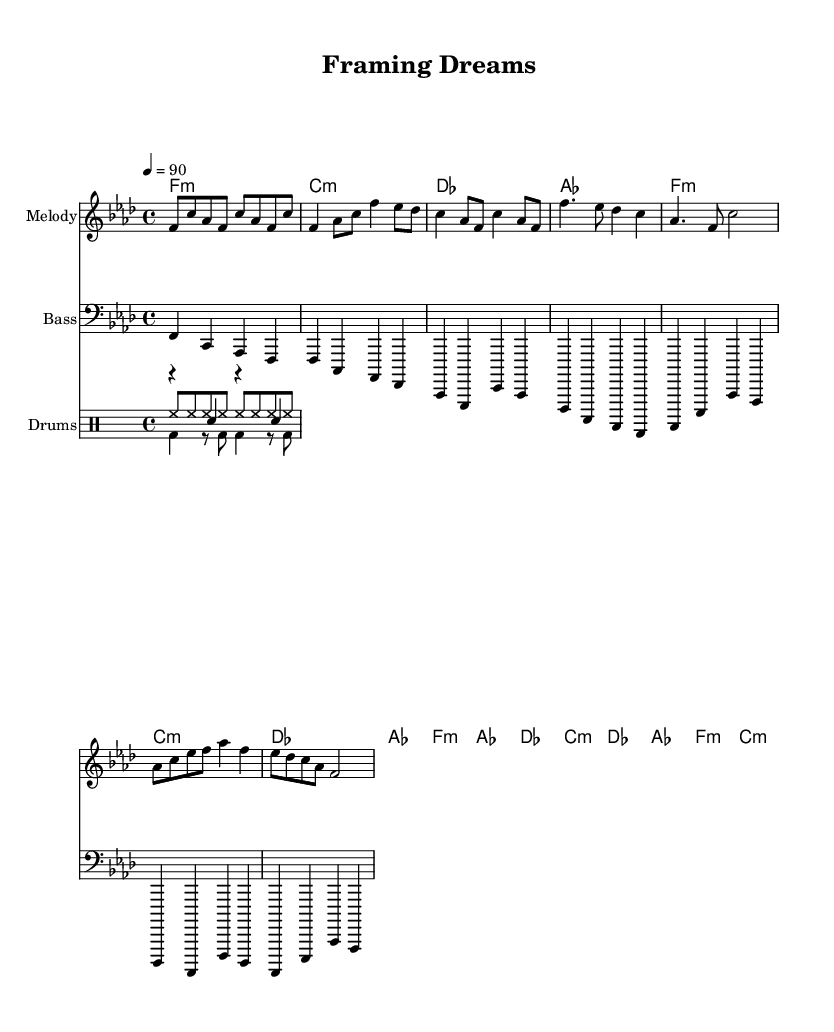What is the key signature of this music? The key signature shows four flats, indicating it is in F minor.
Answer: F minor What is the time signature of the piece? The time signature is indicated at the beginning of the score as 4/4, meaning there are four beats in each measure.
Answer: 4/4 What is the tempo marking of the music? The tempo marking indicates a speed of 90 beats per minute, set at the beginning of the score.
Answer: 90 How many different sections are present in the music? The structure includes an intro, verse, chorus, and bridge, leading to a total of four different sections.
Answer: Four In what section does the melody start? The melody begins at the intro section, which is indicated at the start of the melody part.
Answer: Intro How many different instruments are indicated in the score? The score features three main instruments: Melody, Bass, and Drums, indicating a clear distribution of parts among them.
Answer: Three What type of chords are used in the chorus? The chord progression includes minor and major chords, specifically F minor, A flat major, D flat major, and C minor for the chorus section.
Answer: F minor, A flat major, D flat major, C minor 